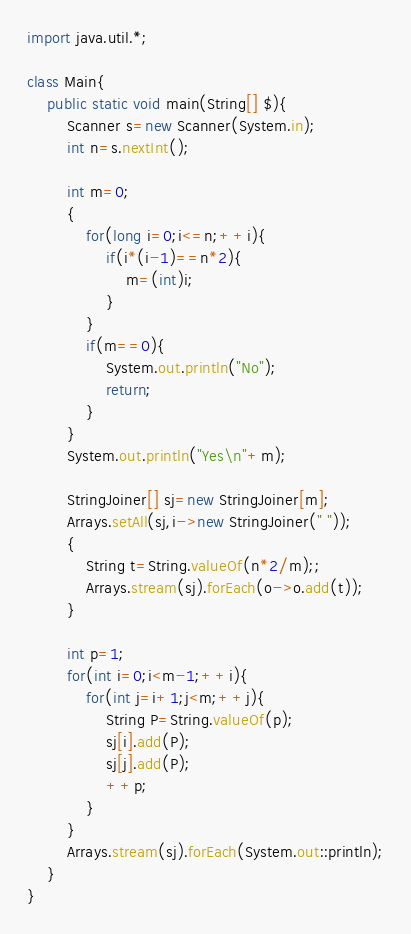Convert code to text. <code><loc_0><loc_0><loc_500><loc_500><_Java_>import java.util.*;

class Main{
	public static void main(String[] $){
		Scanner s=new Scanner(System.in);
		int n=s.nextInt();

		int m=0;
		{
			for(long i=0;i<=n;++i){
				if(i*(i-1)==n*2){
					m=(int)i;
				}
			}
			if(m==0){
				System.out.println("No");
				return;
			}
		}
		System.out.println("Yes\n"+m);

		StringJoiner[] sj=new StringJoiner[m];
		Arrays.setAll(sj,i->new StringJoiner(" "));
		{
			String t=String.valueOf(n*2/m);;
			Arrays.stream(sj).forEach(o->o.add(t));
		}

		int p=1;
		for(int i=0;i<m-1;++i){
			for(int j=i+1;j<m;++j){
				String P=String.valueOf(p);
				sj[i].add(P);
				sj[j].add(P);
				++p;
			}
		}
		Arrays.stream(sj).forEach(System.out::println);
	}
}
</code> 